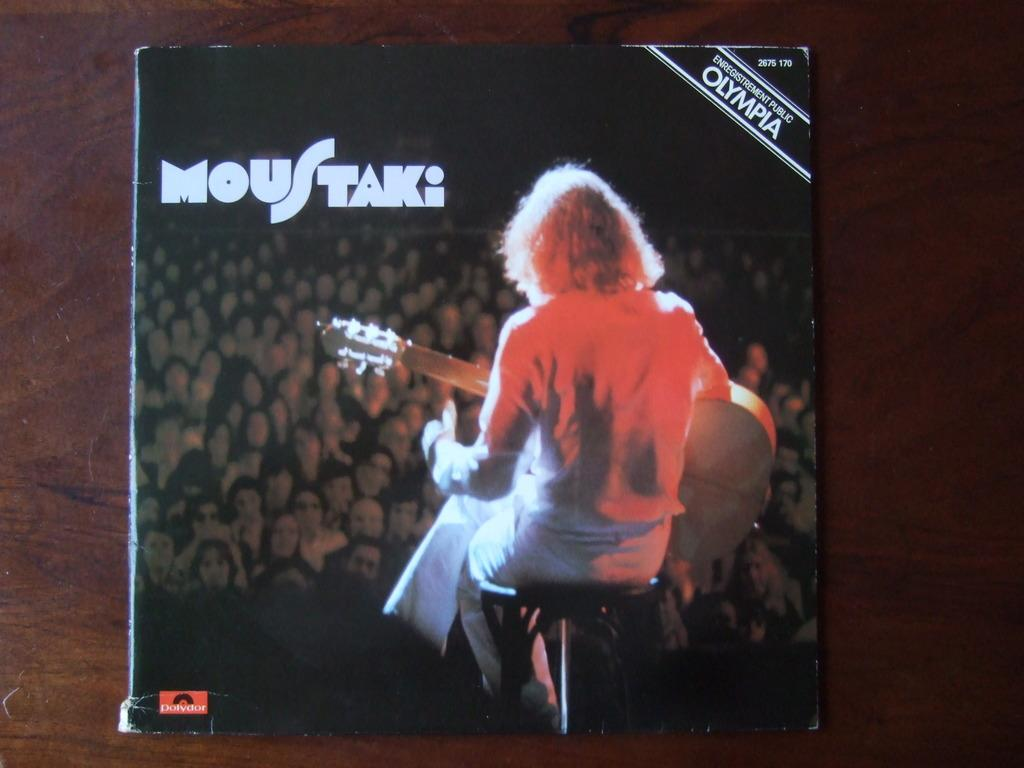<image>
Create a compact narrative representing the image presented. A woman is sitting on stage, with a guitar, on the cover of a album titled MouStaki. 